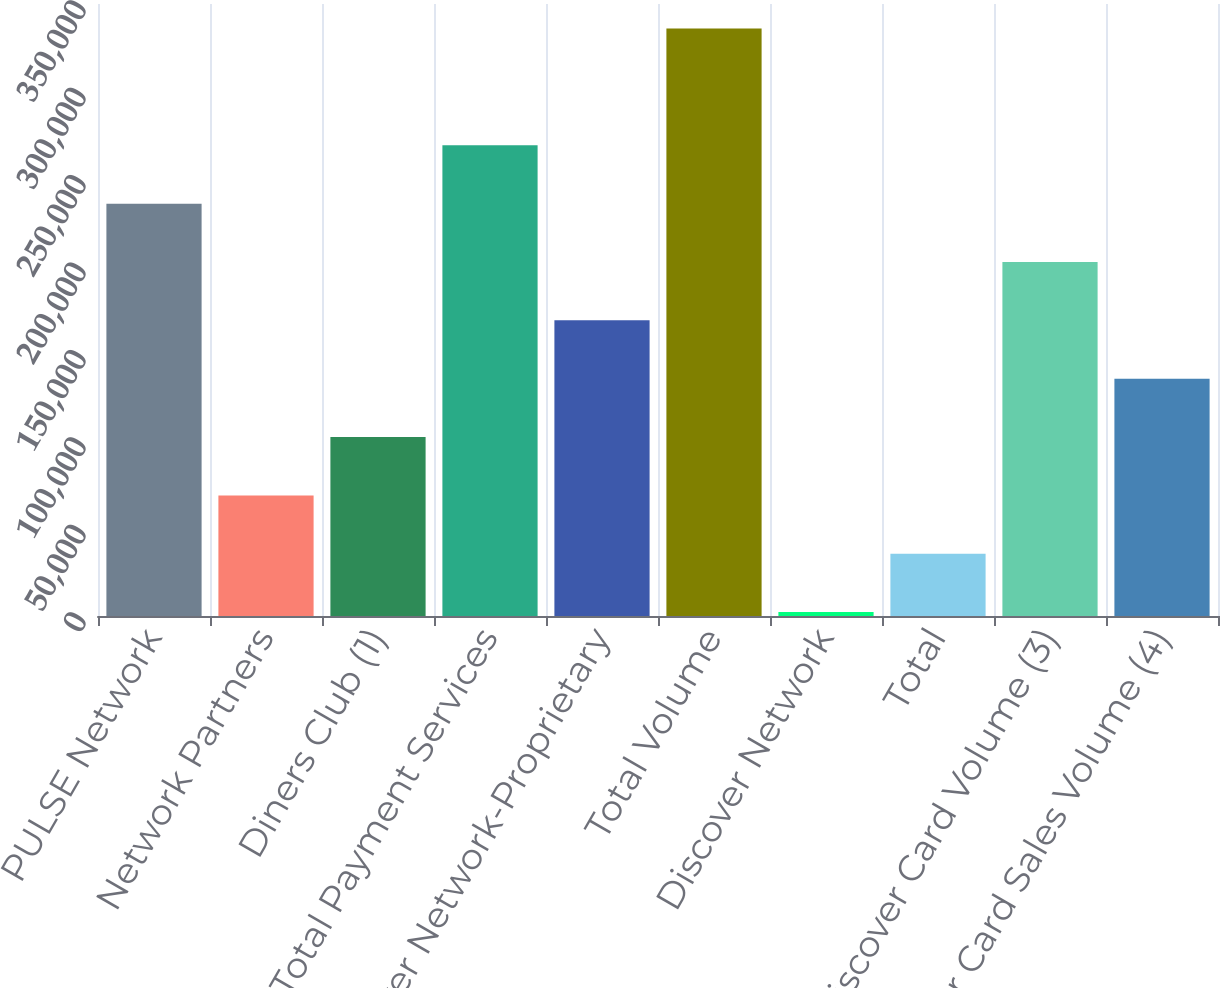Convert chart to OTSL. <chart><loc_0><loc_0><loc_500><loc_500><bar_chart><fcel>PULSE Network<fcel>Network Partners<fcel>Diners Club (1)<fcel>Total Payment Services<fcel>Discover Network-Proprietary<fcel>Total Volume<fcel>Discover Network<fcel>Total<fcel>Discover Card Volume (3)<fcel>Discover Card Sales Volume (4)<nl><fcel>235822<fcel>68977.8<fcel>102347<fcel>269191<fcel>169084<fcel>335929<fcel>2240<fcel>35608.9<fcel>202453<fcel>135716<nl></chart> 